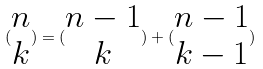Convert formula to latex. <formula><loc_0><loc_0><loc_500><loc_500>( \begin{matrix} n \\ k \end{matrix} ) = ( \begin{matrix} n - 1 \\ k \end{matrix} ) + ( \begin{matrix} n - 1 \\ k - 1 \end{matrix} )</formula> 